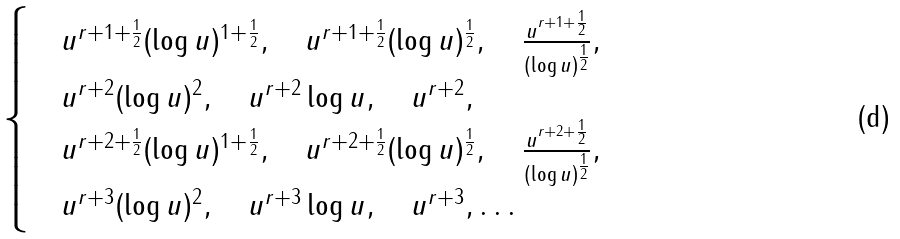Convert formula to latex. <formula><loc_0><loc_0><loc_500><loc_500>\begin{cases} & u ^ { r + 1 + \frac { 1 } { 2 } } ( \log u ) ^ { 1 + \frac { 1 } { 2 } } , \quad u ^ { r + 1 + \frac { 1 } { 2 } } ( \log u ) ^ { \frac { 1 } { 2 } } , \quad \frac { u ^ { r + 1 + \frac { 1 } { 2 } } } { ( \log u ) ^ { \frac { 1 } { 2 } } } , \\ & u ^ { r + 2 } ( \log u ) ^ { 2 } , \quad u ^ { r + 2 } \log u , \quad u ^ { r + 2 } , \\ & u ^ { r + 2 + \frac { 1 } { 2 } } ( \log u ) ^ { 1 + \frac { 1 } { 2 } } , \quad u ^ { r + 2 + \frac { 1 } { 2 } } ( \log u ) ^ { \frac { 1 } { 2 } } , \quad \frac { u ^ { r + 2 + \frac { 1 } { 2 } } } { ( \log u ) ^ { \frac { 1 } { 2 } } } , \\ & u ^ { r + 3 } ( \log u ) ^ { 2 } , \quad u ^ { r + 3 } \log u , \quad u ^ { r + 3 } , \dots \end{cases}</formula> 